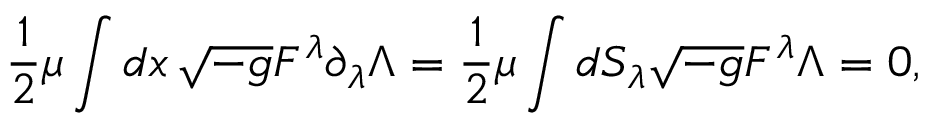<formula> <loc_0><loc_0><loc_500><loc_500>{ \frac { 1 } { 2 } } \mu \int d x \, \sqrt { - g } F ^ { \lambda } \partial _ { \lambda } \Lambda = { \frac { 1 } { 2 } } \mu \int d S _ { \lambda } \sqrt { - g } F ^ { \lambda } \Lambda = 0 ,</formula> 